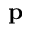Convert formula to latex. <formula><loc_0><loc_0><loc_500><loc_500>p</formula> 